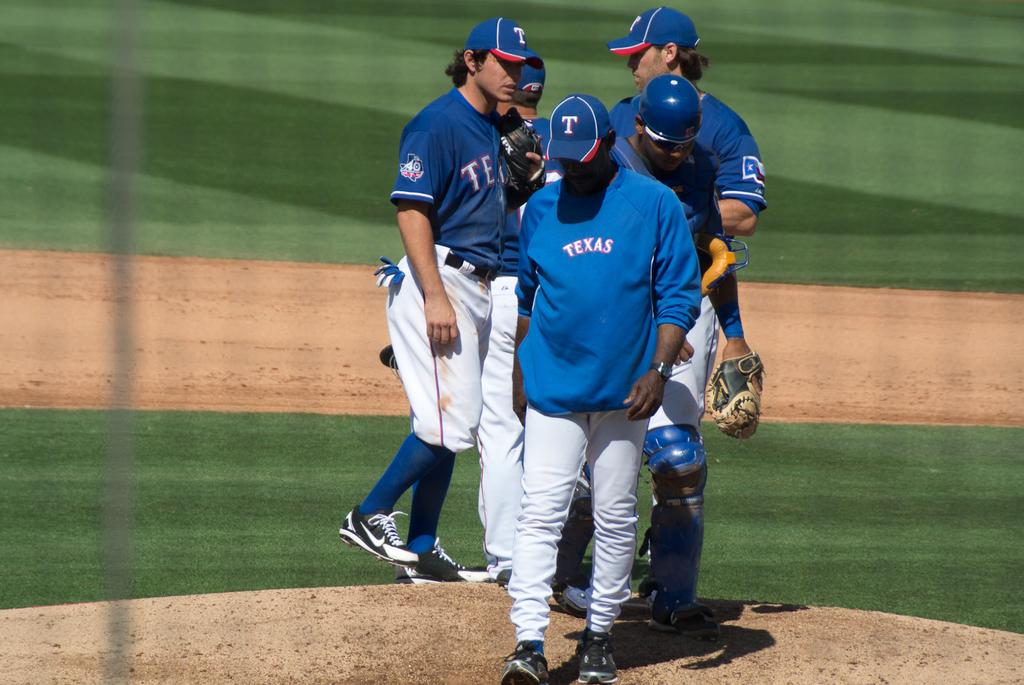<image>
Share a concise interpretation of the image provided. Baseball players that have blue jerseys that have Texas on the front. 